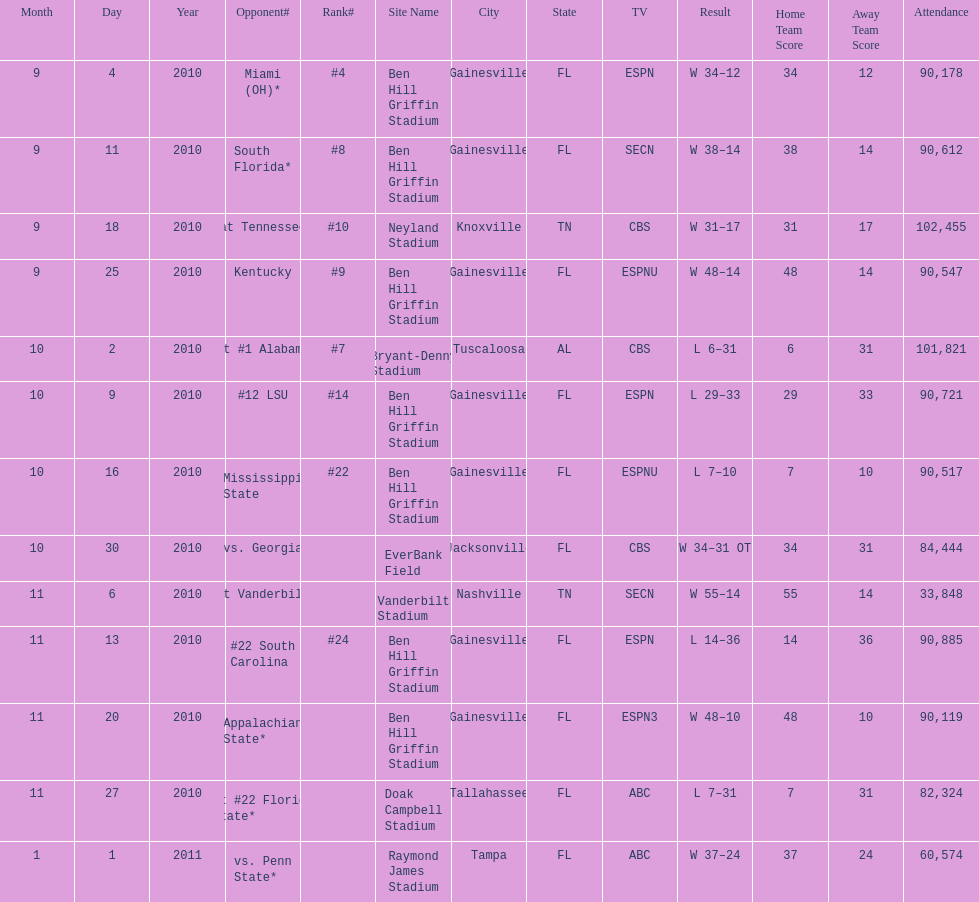How many games were played at the ben hill griffin stadium during the 2010-2011 season? 7. 